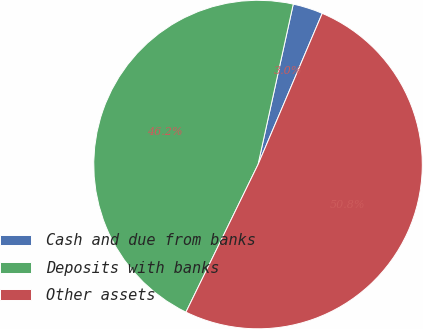Convert chart. <chart><loc_0><loc_0><loc_500><loc_500><pie_chart><fcel>Cash and due from banks<fcel>Deposits with banks<fcel>Other assets<nl><fcel>2.95%<fcel>46.21%<fcel>50.84%<nl></chart> 